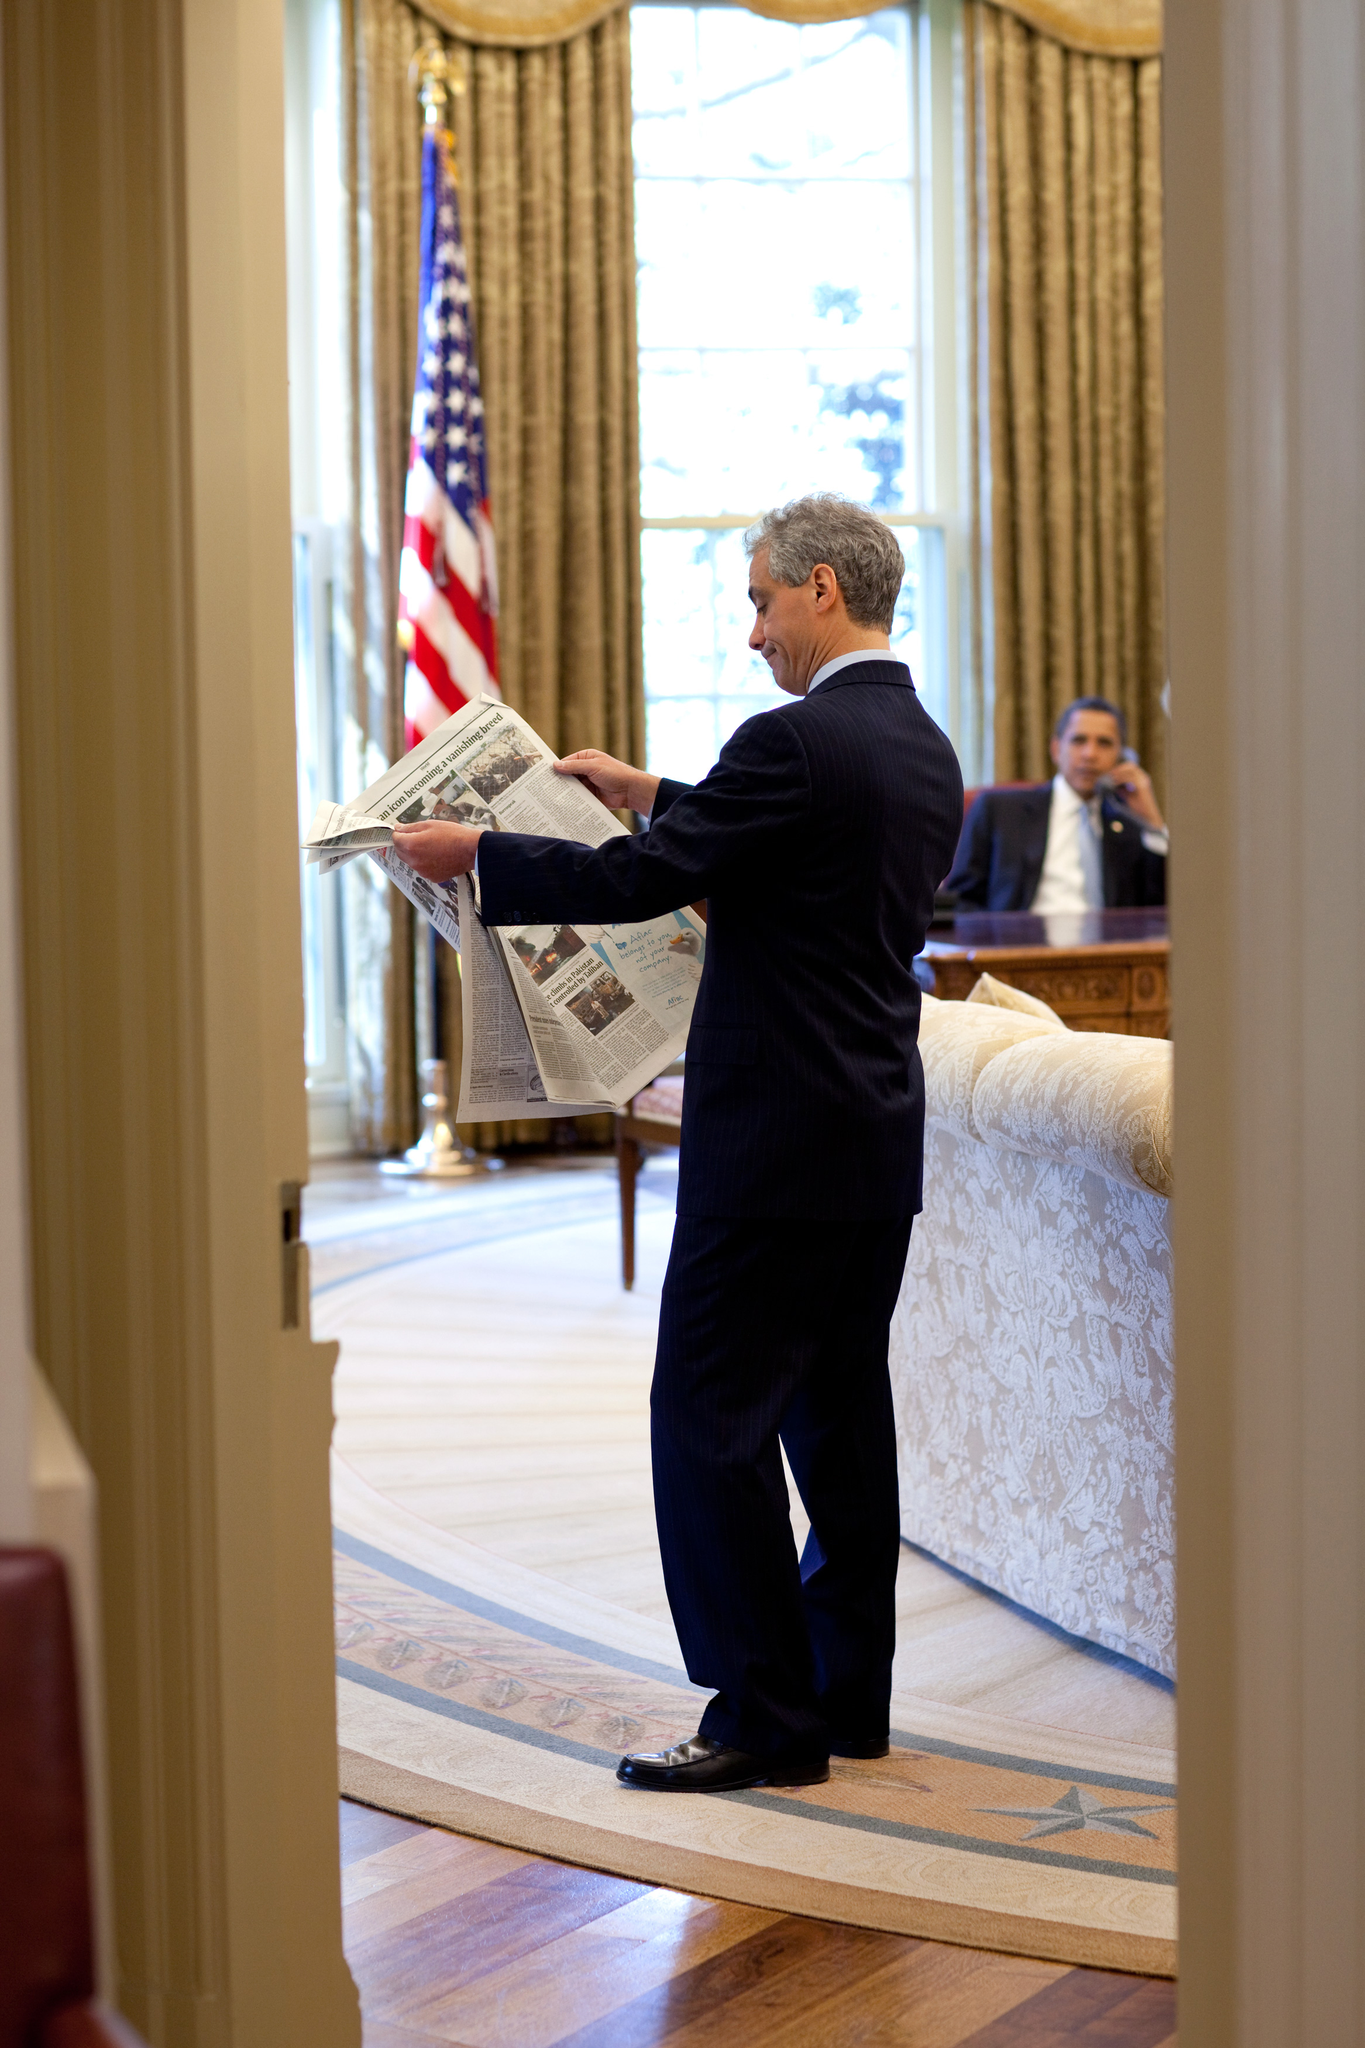How does the physical geography of this place contribute to its overall climate? The physical geography, with high mountain peaks and a significant water body, plays a crucial role in shaping the local climate. The mountains can act as barriers that affect weather patterns, leading to precipitation when moist air rises over them, which could explain the snow caps. Meanwhile, the lake likely moderates the temperature of the surrounding area, preventing extreme temperature variations and creating a generally milder climate ideal for a variety of ecosystems. 